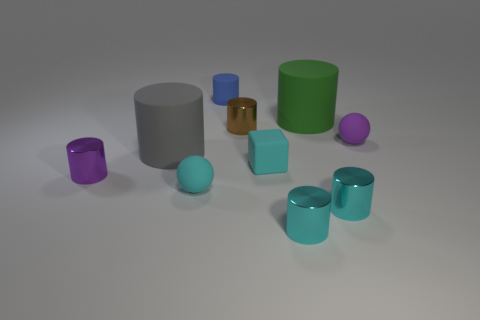How many other objects are the same shape as the blue object? 6 